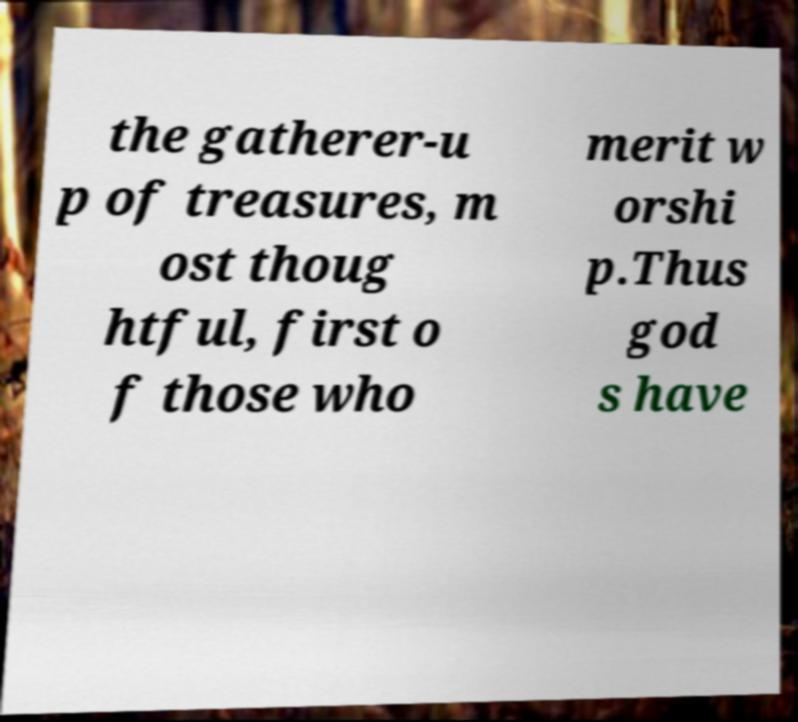Could you assist in decoding the text presented in this image and type it out clearly? the gatherer-u p of treasures, m ost thoug htful, first o f those who merit w orshi p.Thus god s have 